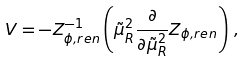<formula> <loc_0><loc_0><loc_500><loc_500>V = - Z _ { \phi , r e n } ^ { - 1 } \left ( \tilde { \mu } _ { R } ^ { 2 } \frac { \partial } { \partial \tilde { \mu } _ { R } ^ { 2 } } Z _ { \phi , r e n } \right ) \, ,</formula> 